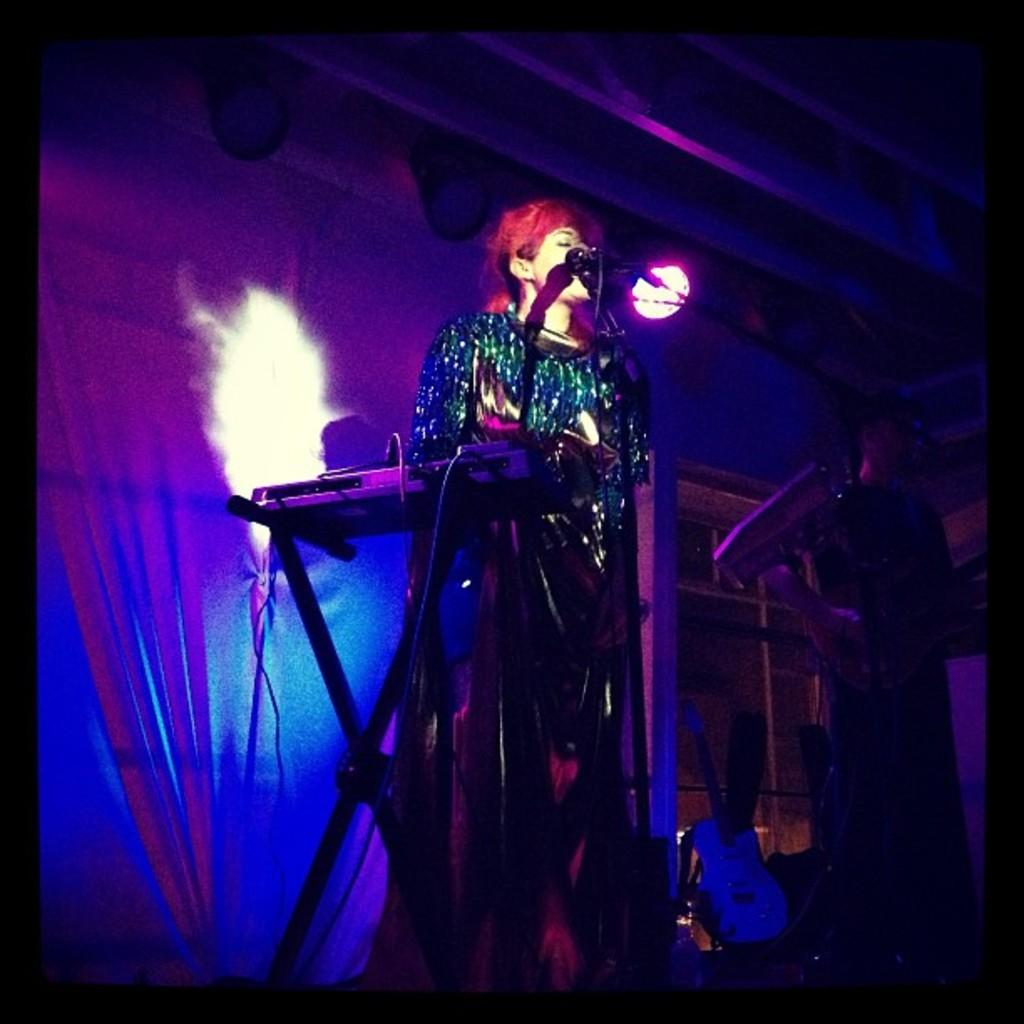What is the main subject of the image? There is a person in the image. What is the person doing in the image? The person is playing a musical instrument. What object is the person positioned near? The person is in front of a microphone. What can be seen in the background or surrounding area of the image? There is a light visible in the image. What type of cream can be seen in the person's nest in the image? There is no nest or cream present in the image; it features a person playing a musical instrument in front of a microphone. 